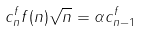<formula> <loc_0><loc_0><loc_500><loc_500>c _ { n } ^ { f } f ( n ) \sqrt { n } = \alpha c _ { n - 1 } ^ { f }</formula> 